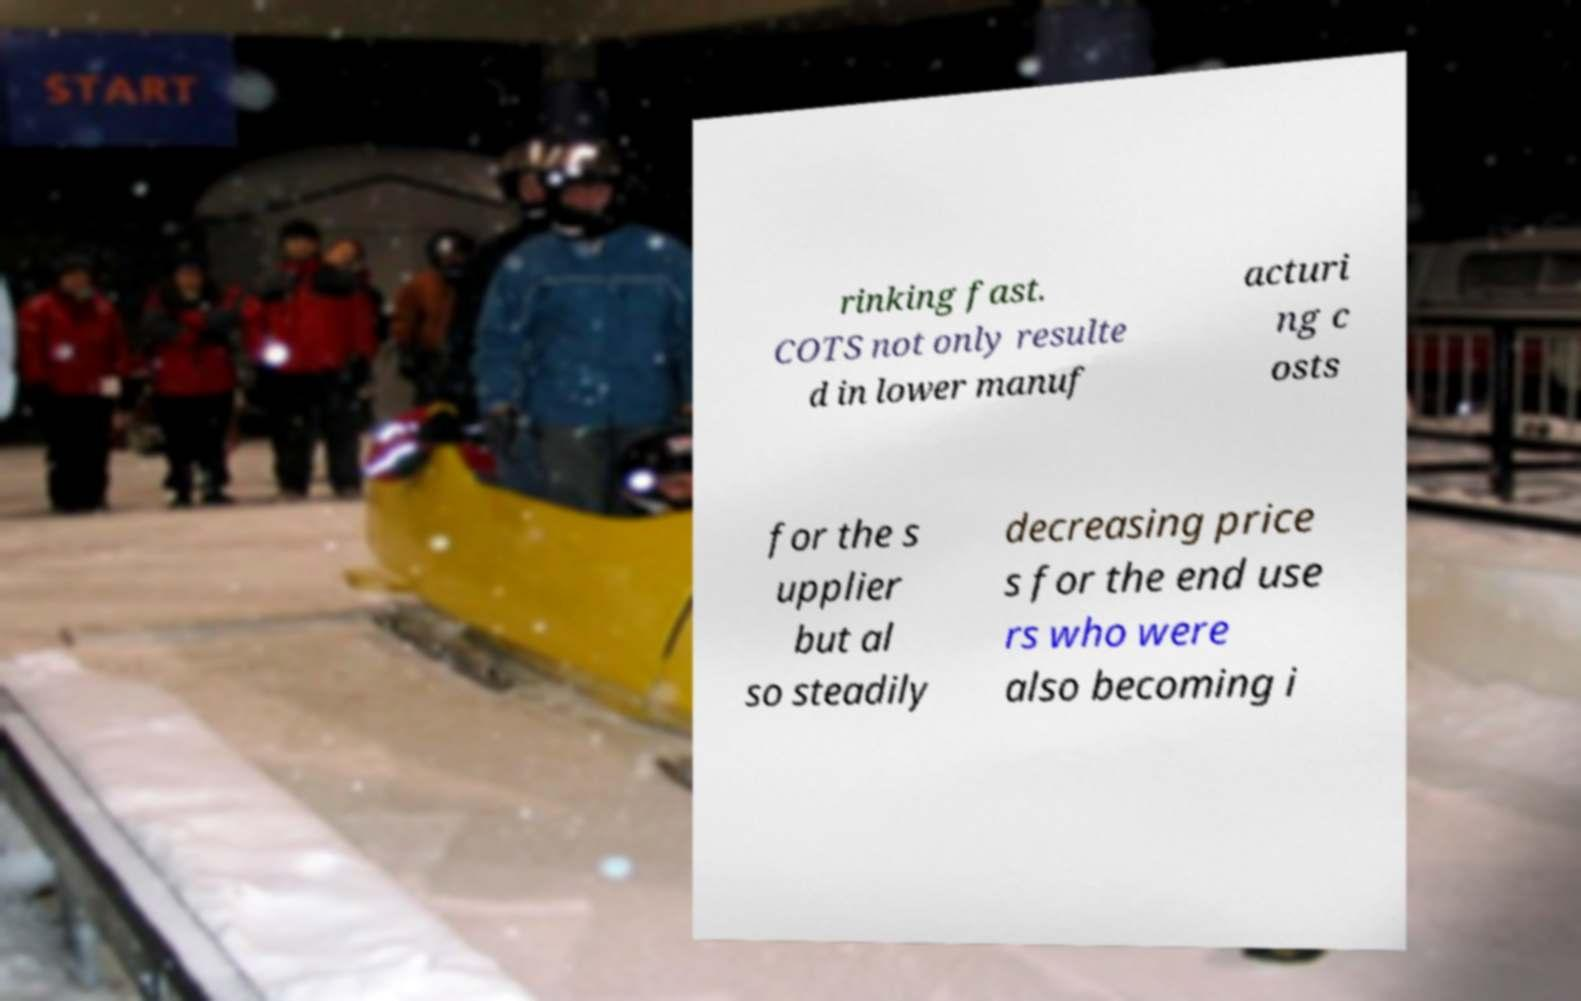Could you assist in decoding the text presented in this image and type it out clearly? rinking fast. COTS not only resulte d in lower manuf acturi ng c osts for the s upplier but al so steadily decreasing price s for the end use rs who were also becoming i 